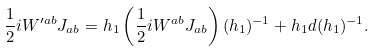Convert formula to latex. <formula><loc_0><loc_0><loc_500><loc_500>\frac { 1 } { 2 } i W ^ { \prime a b } { J } _ { a b } = h _ { 1 } \left ( \frac { 1 } { 2 } i W ^ { a b } { J } _ { a b } \right ) ( h _ { 1 } ) ^ { - 1 } + h _ { 1 } d ( h _ { 1 } ) ^ { - 1 } .</formula> 